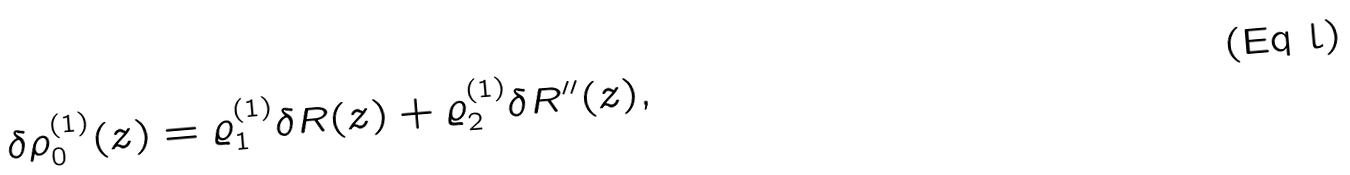<formula> <loc_0><loc_0><loc_500><loc_500>\delta \rho ^ { ( 1 ) } _ { 0 } ( z ) = \varrho ^ { ( 1 ) } _ { 1 } \delta R ( z ) + \varrho ^ { ( 1 ) } _ { 2 } \delta R ^ { \prime \prime } ( z ) ,</formula> 